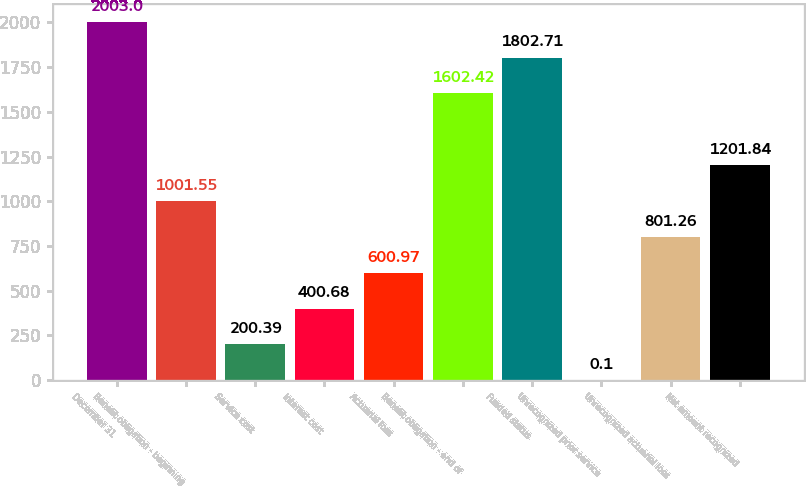Convert chart. <chart><loc_0><loc_0><loc_500><loc_500><bar_chart><fcel>December 31<fcel>Benefit obligation - beginning<fcel>Service cost<fcel>Interest cost<fcel>Actuarial loss<fcel>Benefit obligation - end of<fcel>Funded status<fcel>Unrecognized prior service<fcel>Unrecognized actuarial loss<fcel>Net amount recognized<nl><fcel>2003<fcel>1001.55<fcel>200.39<fcel>400.68<fcel>600.97<fcel>1602.42<fcel>1802.71<fcel>0.1<fcel>801.26<fcel>1201.84<nl></chart> 